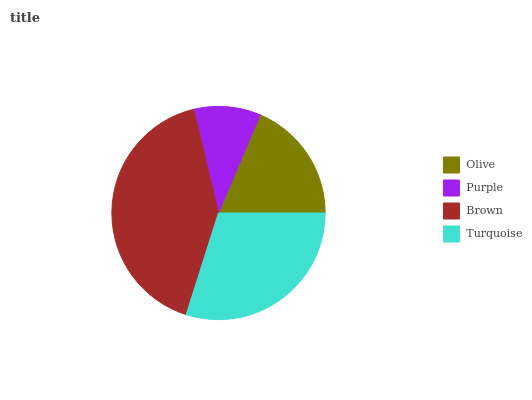Is Purple the minimum?
Answer yes or no. Yes. Is Brown the maximum?
Answer yes or no. Yes. Is Brown the minimum?
Answer yes or no. No. Is Purple the maximum?
Answer yes or no. No. Is Brown greater than Purple?
Answer yes or no. Yes. Is Purple less than Brown?
Answer yes or no. Yes. Is Purple greater than Brown?
Answer yes or no. No. Is Brown less than Purple?
Answer yes or no. No. Is Turquoise the high median?
Answer yes or no. Yes. Is Olive the low median?
Answer yes or no. Yes. Is Brown the high median?
Answer yes or no. No. Is Brown the low median?
Answer yes or no. No. 